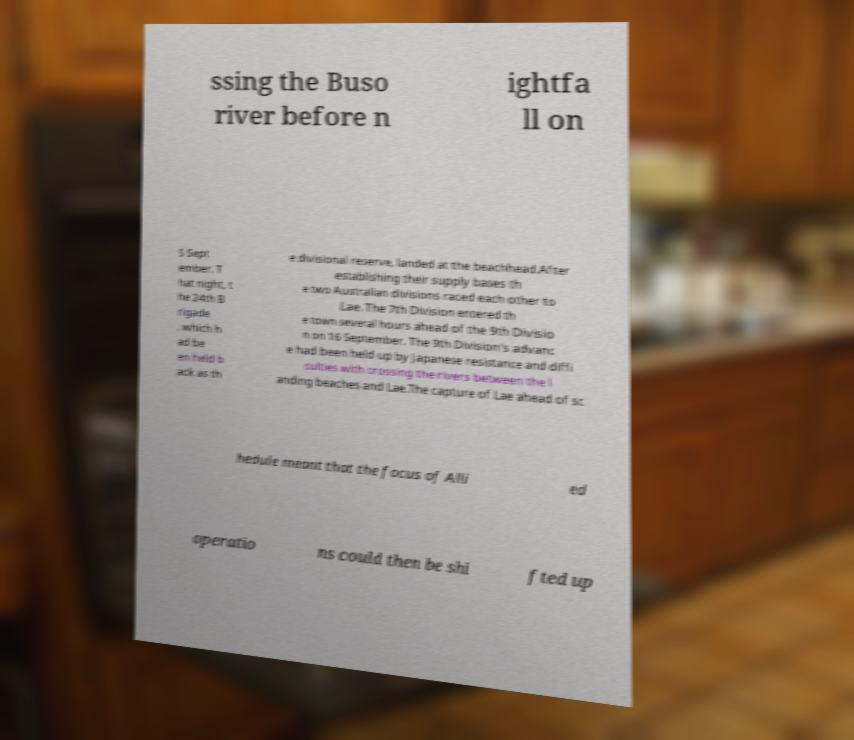There's text embedded in this image that I need extracted. Can you transcribe it verbatim? ssing the Buso river before n ightfa ll on 5 Sept ember. T hat night, t he 24th B rigade , which h ad be en held b ack as th e divisional reserve, landed at the beachhead.After establishing their supply bases th e two Australian divisions raced each other to Lae. The 7th Division entered th e town several hours ahead of the 9th Divisio n on 16 September. The 9th Division's advanc e had been held up by Japanese resistance and diffi culties with crossing the rivers between the l anding beaches and Lae.The capture of Lae ahead of sc hedule meant that the focus of Alli ed operatio ns could then be shi fted up 